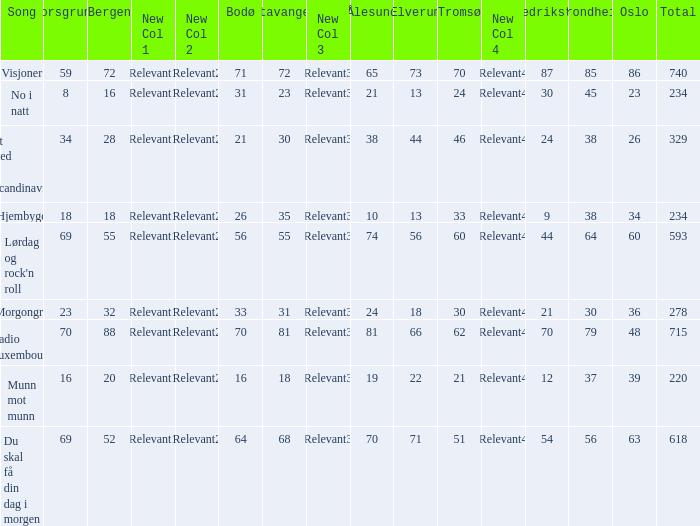How many elverum are tehre for et sted i scandinavia? 1.0. 